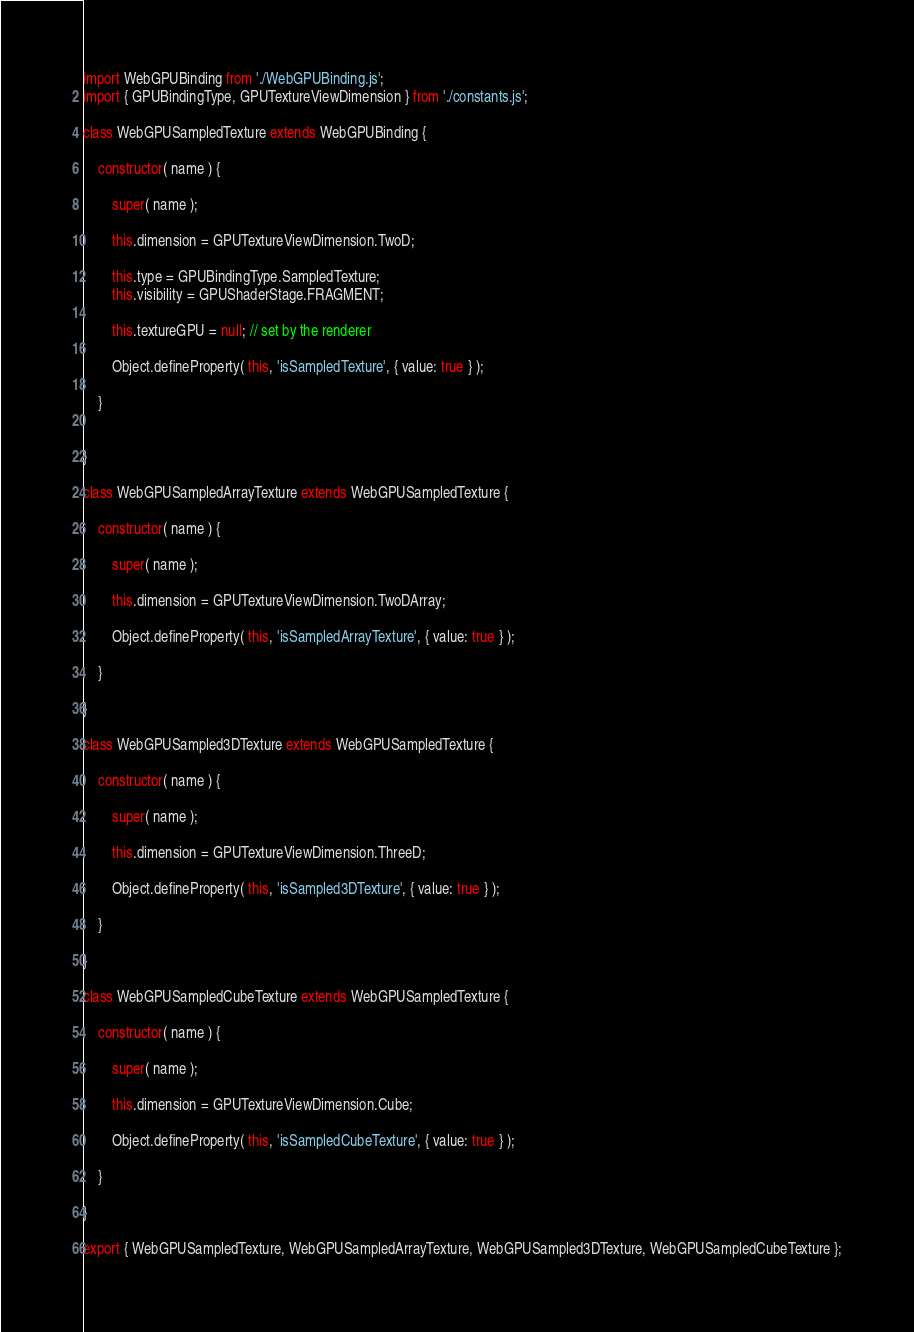Convert code to text. <code><loc_0><loc_0><loc_500><loc_500><_JavaScript_>import WebGPUBinding from './WebGPUBinding.js';
import { GPUBindingType, GPUTextureViewDimension } from './constants.js';

class WebGPUSampledTexture extends WebGPUBinding {

	constructor( name ) {

		super( name );

		this.dimension = GPUTextureViewDimension.TwoD;

		this.type = GPUBindingType.SampledTexture;
		this.visibility = GPUShaderStage.FRAGMENT;

		this.textureGPU = null; // set by the renderer

		Object.defineProperty( this, 'isSampledTexture', { value: true } );

	}


}

class WebGPUSampledArrayTexture extends WebGPUSampledTexture {

	constructor( name ) {

		super( name );

		this.dimension = GPUTextureViewDimension.TwoDArray;

		Object.defineProperty( this, 'isSampledArrayTexture', { value: true } );

	}

}

class WebGPUSampled3DTexture extends WebGPUSampledTexture {

	constructor( name ) {

		super( name );

		this.dimension = GPUTextureViewDimension.ThreeD;

		Object.defineProperty( this, 'isSampled3DTexture', { value: true } );

	}

}

class WebGPUSampledCubeTexture extends WebGPUSampledTexture {

	constructor( name ) {

		super( name );

		this.dimension = GPUTextureViewDimension.Cube;

		Object.defineProperty( this, 'isSampledCubeTexture', { value: true } );

	}

}

export { WebGPUSampledTexture, WebGPUSampledArrayTexture, WebGPUSampled3DTexture, WebGPUSampledCubeTexture };
</code> 